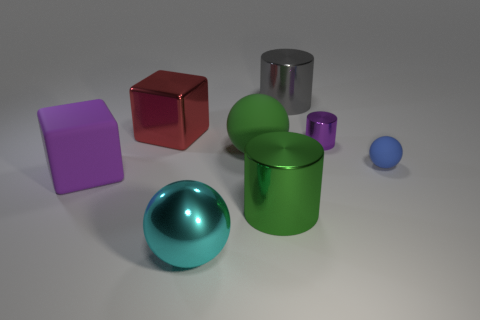The big gray thing that is the same material as the red thing is what shape?
Offer a terse response. Cylinder. How many other things are the same shape as the large red metal thing?
Make the answer very short. 1. There is a green shiny object that is to the right of the large purple object; what is its shape?
Your answer should be very brief. Cylinder. What is the color of the tiny rubber ball?
Give a very brief answer. Blue. What number of other things are there of the same size as the shiny cube?
Provide a short and direct response. 5. The tiny object that is in front of the purple object that is behind the large purple thing is made of what material?
Your answer should be very brief. Rubber. There is a gray object; does it have the same size as the purple object on the right side of the big cyan metal sphere?
Ensure brevity in your answer.  No. Are there any metallic cylinders that have the same color as the tiny sphere?
Give a very brief answer. No. What number of small objects are purple things or gray shiny blocks?
Keep it short and to the point. 1. How many big purple rubber things are there?
Your response must be concise. 1. 